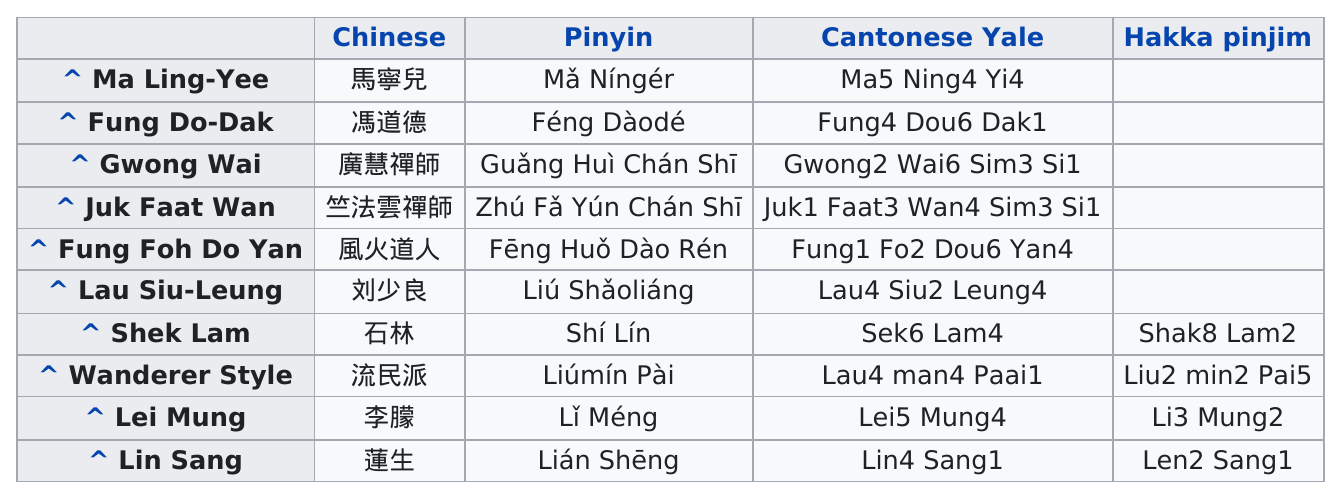Indicate a few pertinent items in this graphic. The first item listed before 'juk faat wan' in the first column is '^ Gwong Wai'. The pinyin for the character "Lián Shēng" is listed last among the other pinyin readings for that character. The last item listed in the first column is "Lin Sang. What is listed first in the pinyin column? It is the name "Mǎ Níngér... The person listed last is Lin Sang. 